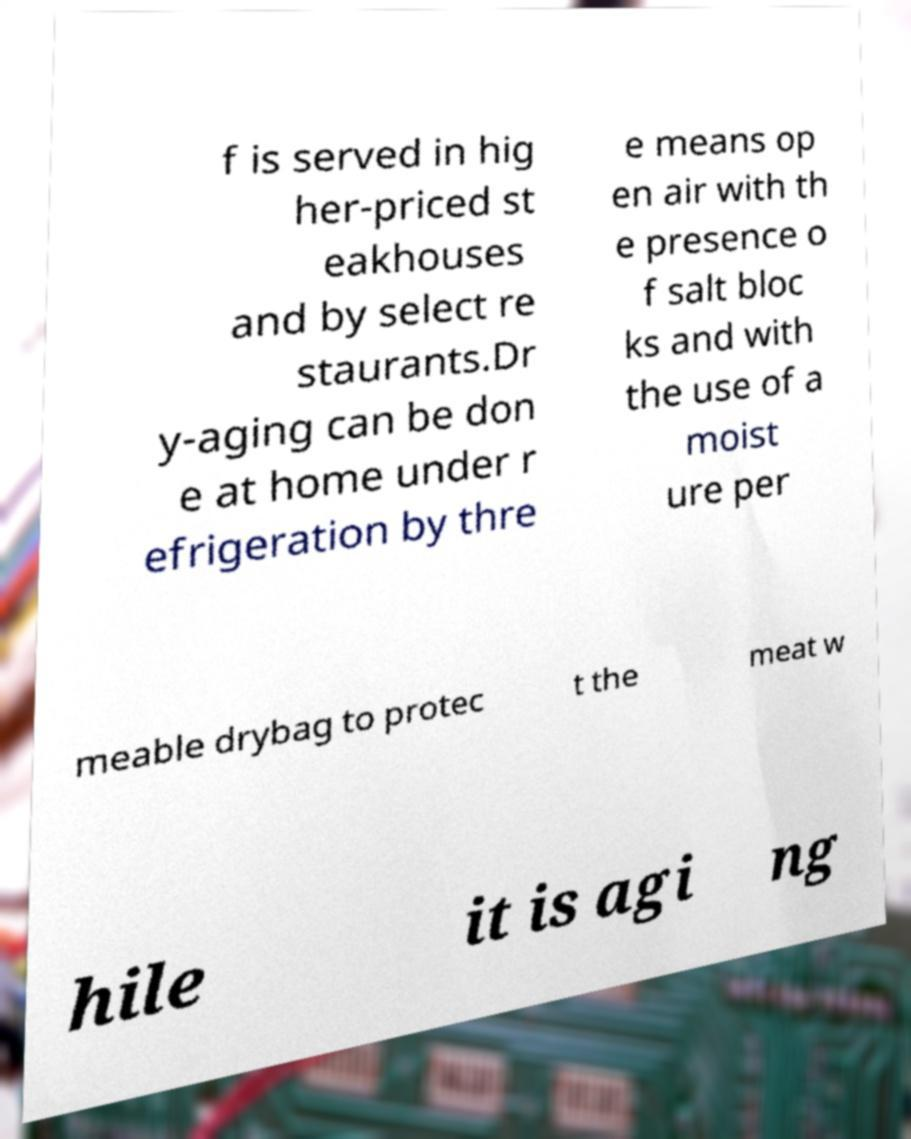Can you accurately transcribe the text from the provided image for me? f is served in hig her-priced st eakhouses and by select re staurants.Dr y-aging can be don e at home under r efrigeration by thre e means op en air with th e presence o f salt bloc ks and with the use of a moist ure per meable drybag to protec t the meat w hile it is agi ng 